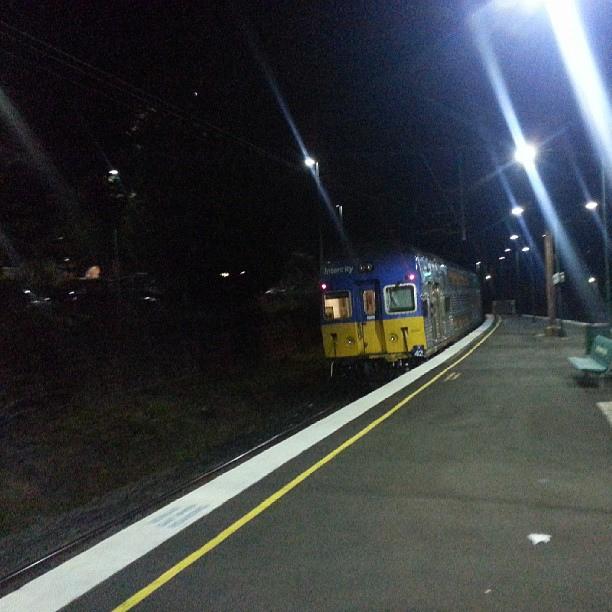Is this vehicle commonly owned?
Answer briefly. No. Are there people waiting for the train?
Write a very short answer. No. Is it daytime or evening?
Give a very brief answer. Evening. 